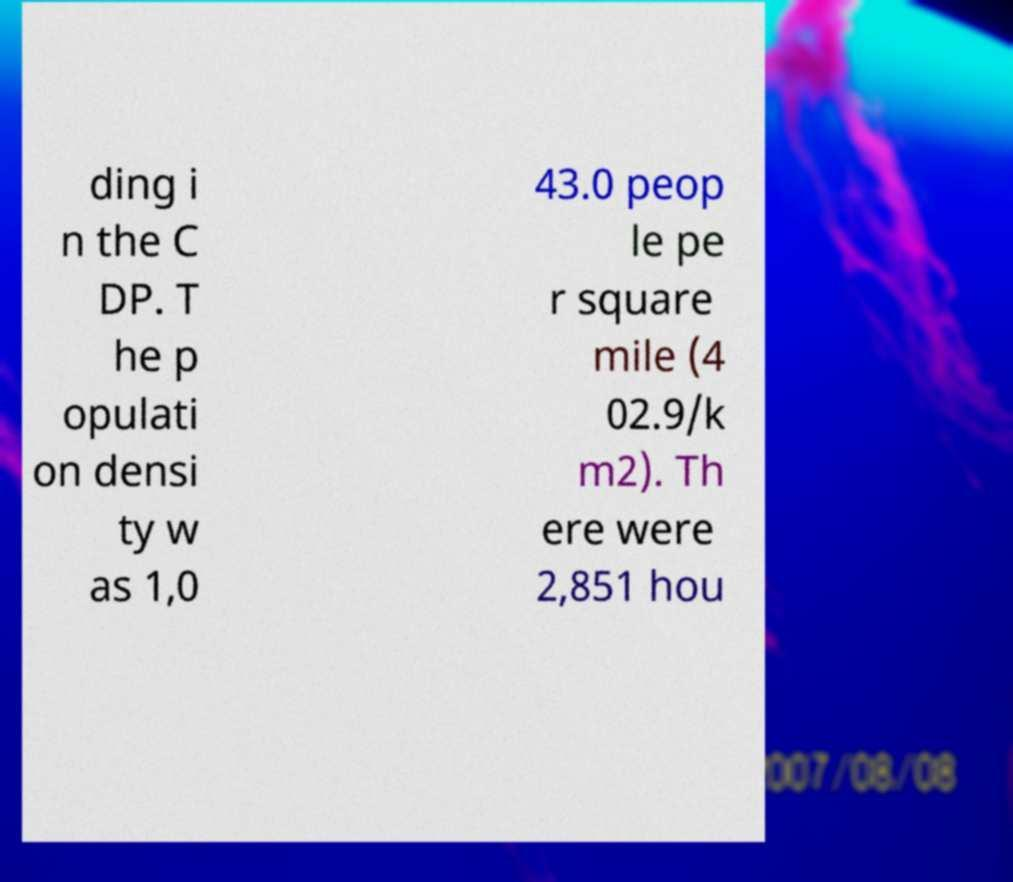Could you assist in decoding the text presented in this image and type it out clearly? ding i n the C DP. T he p opulati on densi ty w as 1,0 43.0 peop le pe r square mile (4 02.9/k m2). Th ere were 2,851 hou 